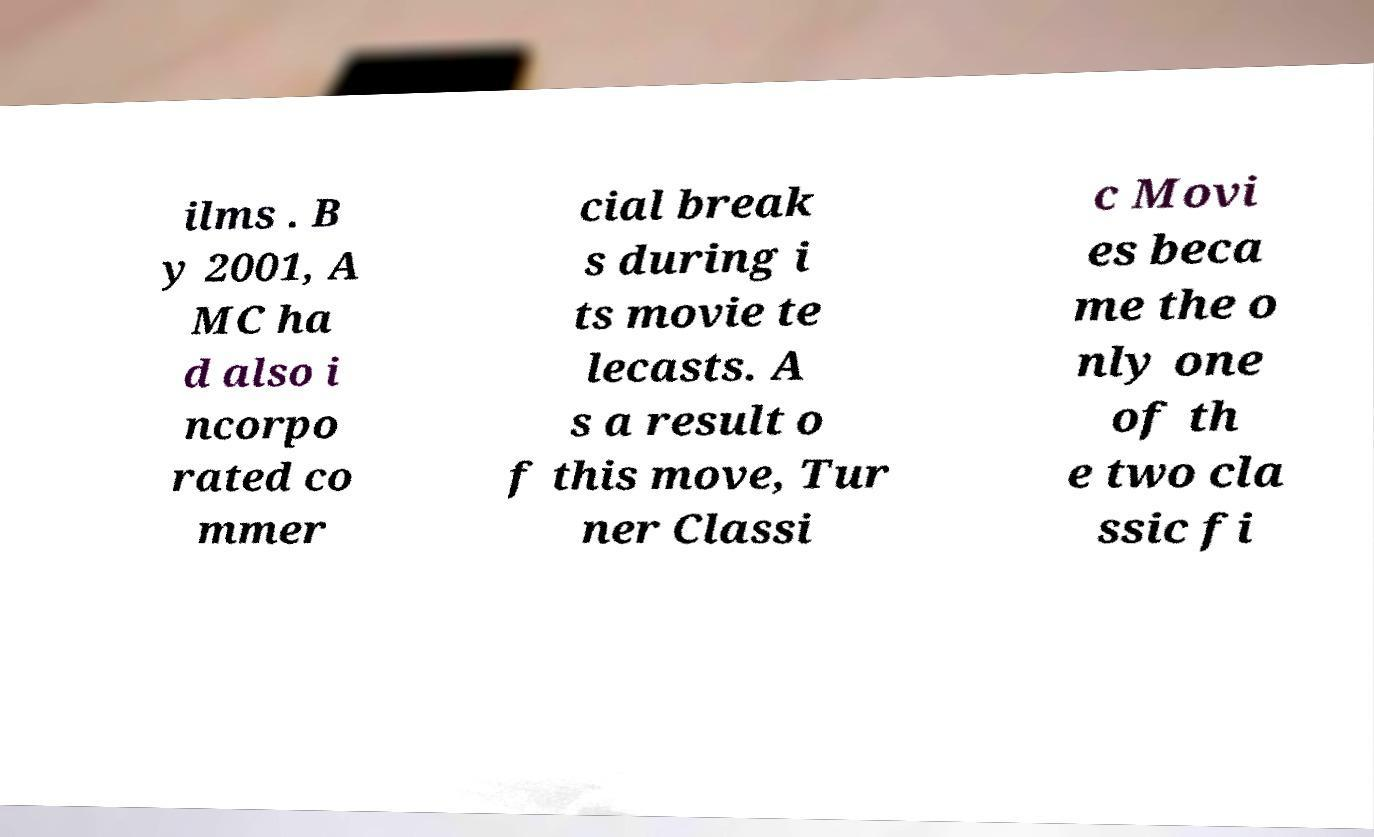Could you extract and type out the text from this image? ilms . B y 2001, A MC ha d also i ncorpo rated co mmer cial break s during i ts movie te lecasts. A s a result o f this move, Tur ner Classi c Movi es beca me the o nly one of th e two cla ssic fi 